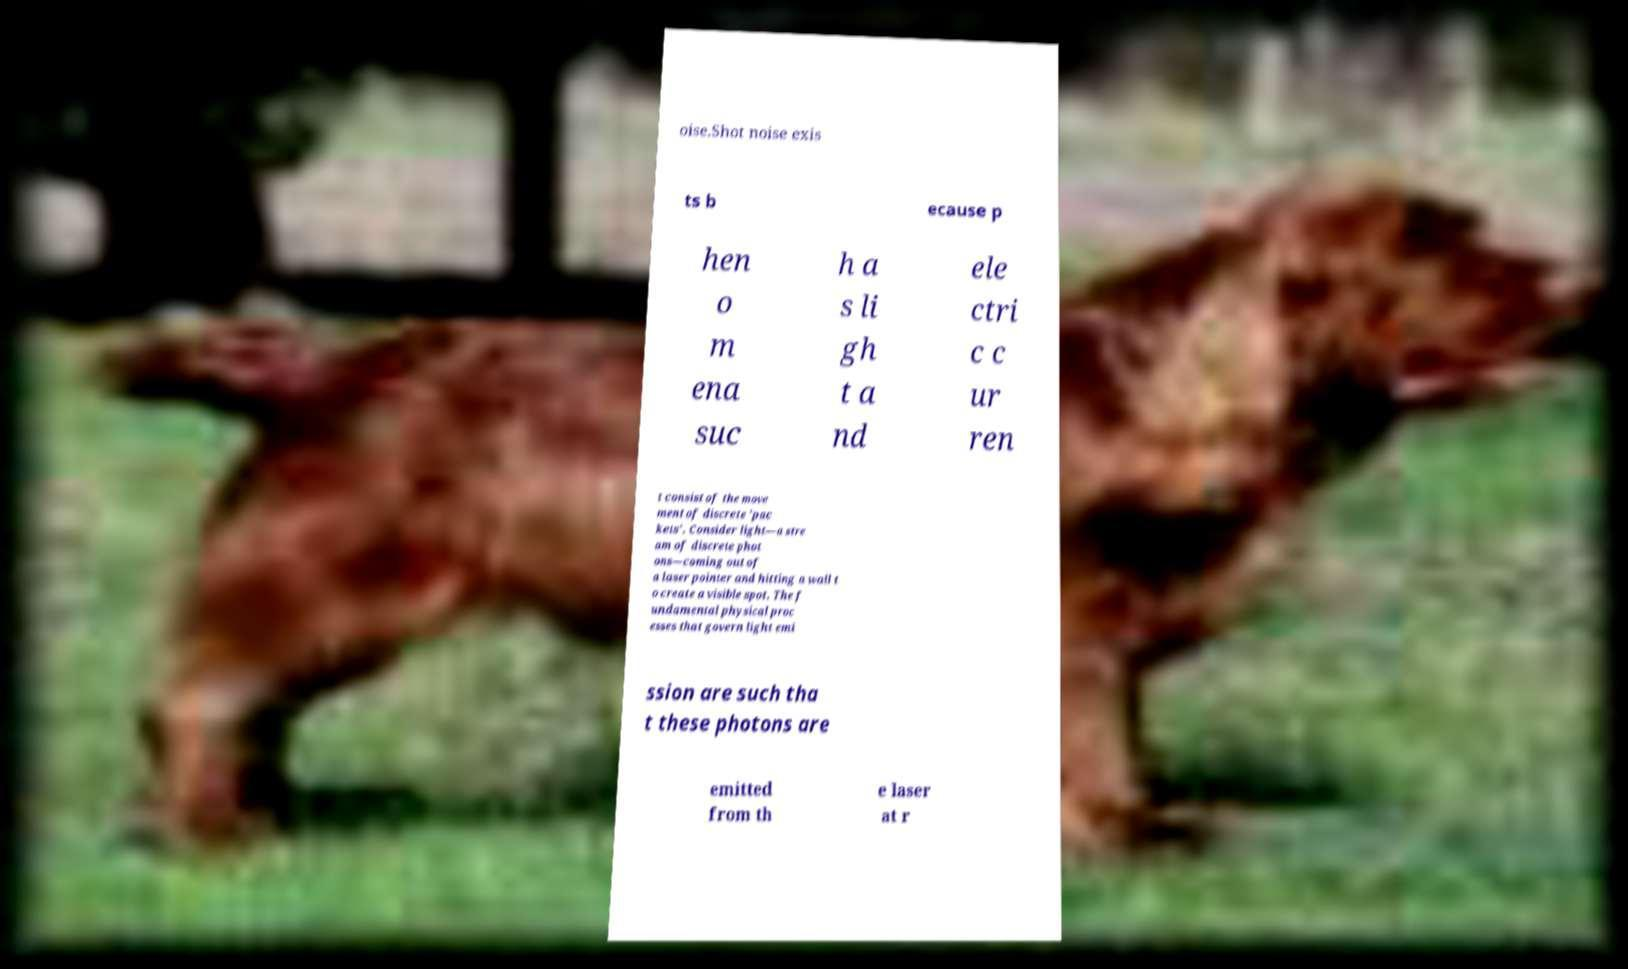Please read and relay the text visible in this image. What does it say? oise.Shot noise exis ts b ecause p hen o m ena suc h a s li gh t a nd ele ctri c c ur ren t consist of the move ment of discrete 'pac kets'. Consider light—a stre am of discrete phot ons—coming out of a laser pointer and hitting a wall t o create a visible spot. The f undamental physical proc esses that govern light emi ssion are such tha t these photons are emitted from th e laser at r 